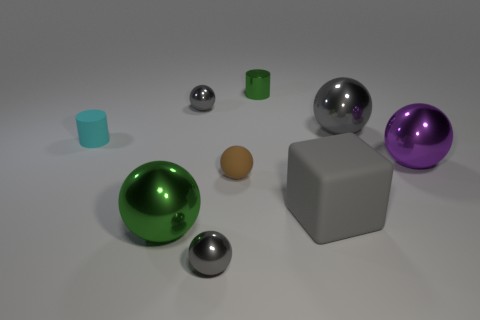What number of brown objects are the same shape as the small cyan thing?
Provide a succinct answer. 0. Do the cylinder that is on the right side of the large green thing and the large matte cube have the same color?
Offer a terse response. No. What number of cyan things are on the left side of the gray shiny ball right of the small gray shiny sphere that is in front of the tiny cyan matte object?
Provide a short and direct response. 1. What number of shiny objects are both behind the small brown thing and in front of the small green shiny thing?
Your answer should be compact. 3. Does the large gray block have the same material as the small brown thing?
Your answer should be very brief. Yes. There is a green object that is to the left of the tiny gray sphere in front of the green object in front of the big matte object; what is its shape?
Offer a very short reply. Sphere. Is the number of large balls that are behind the green metal ball less than the number of small objects in front of the tiny cyan rubber thing?
Your answer should be compact. No. There is a shiny object behind the small gray shiny object behind the brown object; what shape is it?
Your answer should be compact. Cylinder. Is there any other thing that has the same color as the large rubber object?
Offer a very short reply. Yes. Is the color of the large cube the same as the small rubber ball?
Your response must be concise. No. 